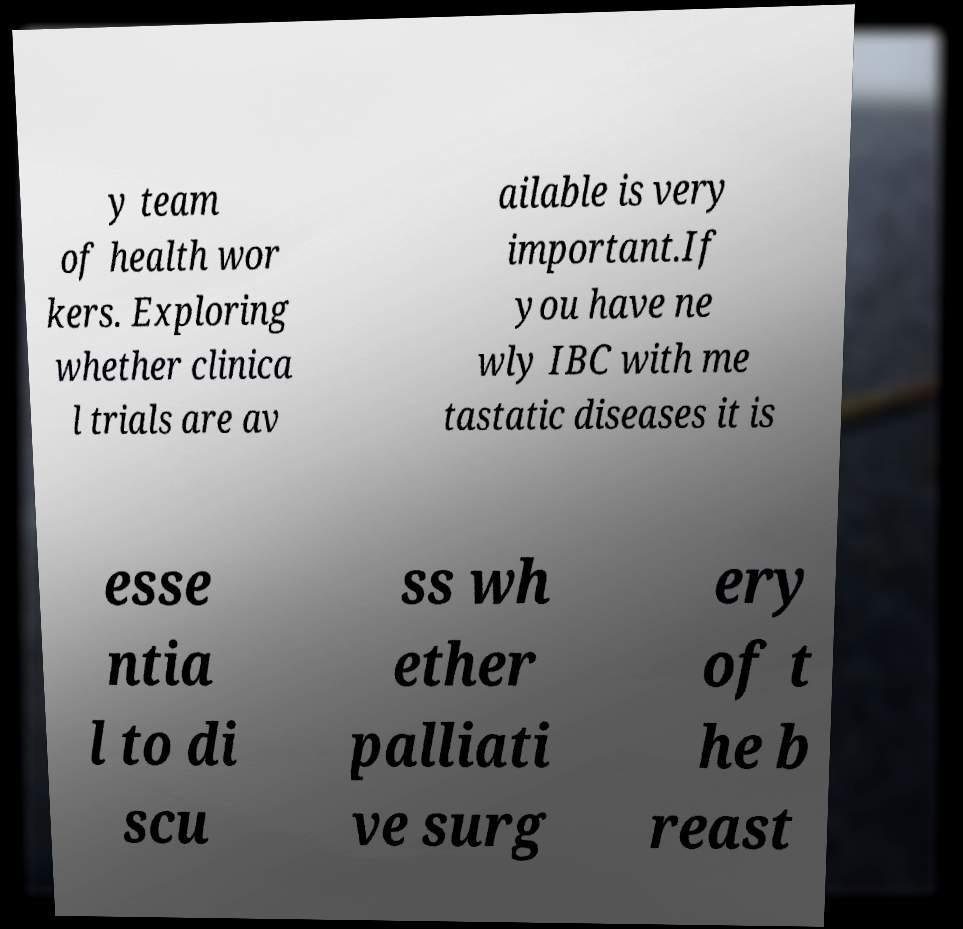Can you read and provide the text displayed in the image?This photo seems to have some interesting text. Can you extract and type it out for me? y team of health wor kers. Exploring whether clinica l trials are av ailable is very important.If you have ne wly IBC with me tastatic diseases it is esse ntia l to di scu ss wh ether palliati ve surg ery of t he b reast 